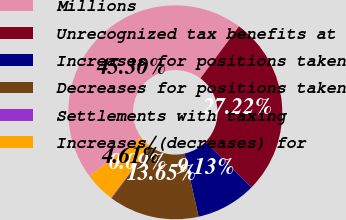Convert chart. <chart><loc_0><loc_0><loc_500><loc_500><pie_chart><fcel>Millions<fcel>Unrecognized tax benefits at<fcel>Increases for positions taken<fcel>Decreases for positions taken<fcel>Settlements with taxing<fcel>Increases/(decreases) for<nl><fcel>45.3%<fcel>27.22%<fcel>9.13%<fcel>13.65%<fcel>0.09%<fcel>4.61%<nl></chart> 